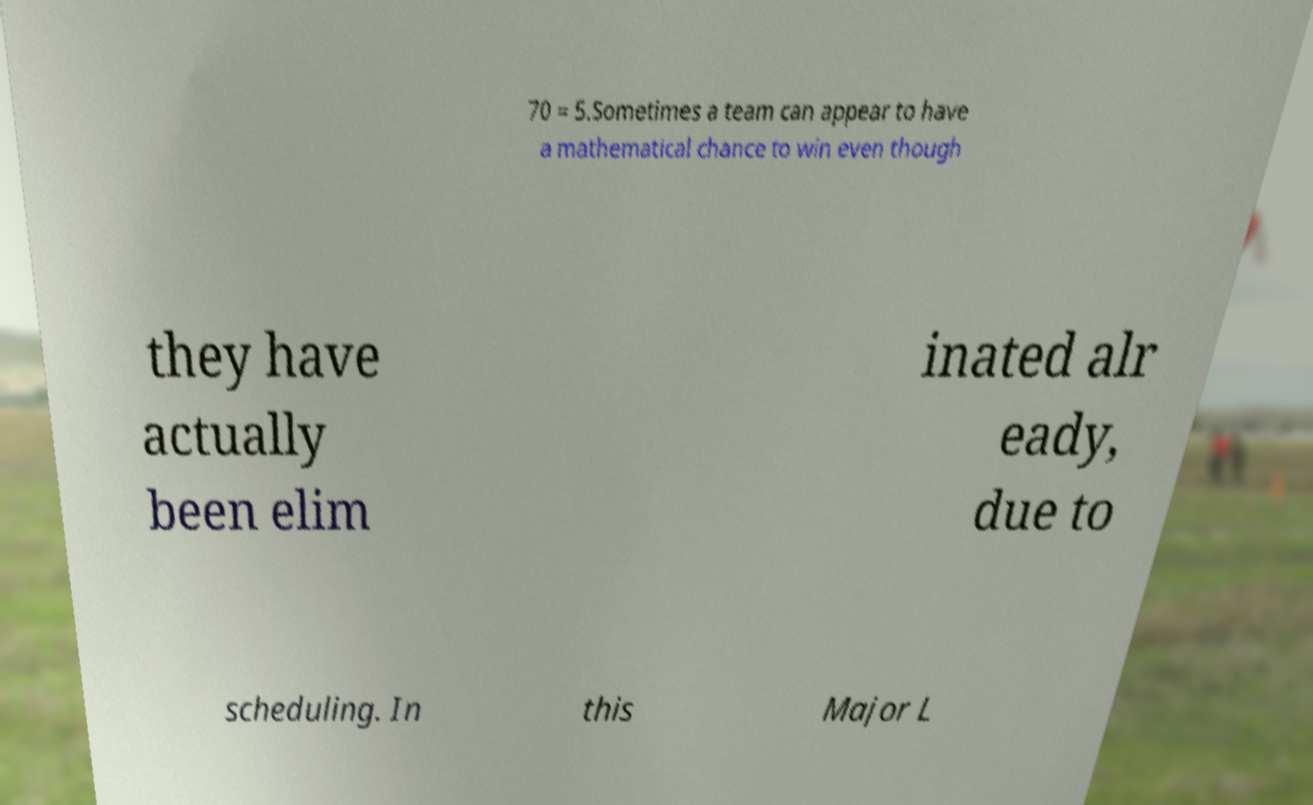What messages or text are displayed in this image? I need them in a readable, typed format. 70 = 5.Sometimes a team can appear to have a mathematical chance to win even though they have actually been elim inated alr eady, due to scheduling. In this Major L 